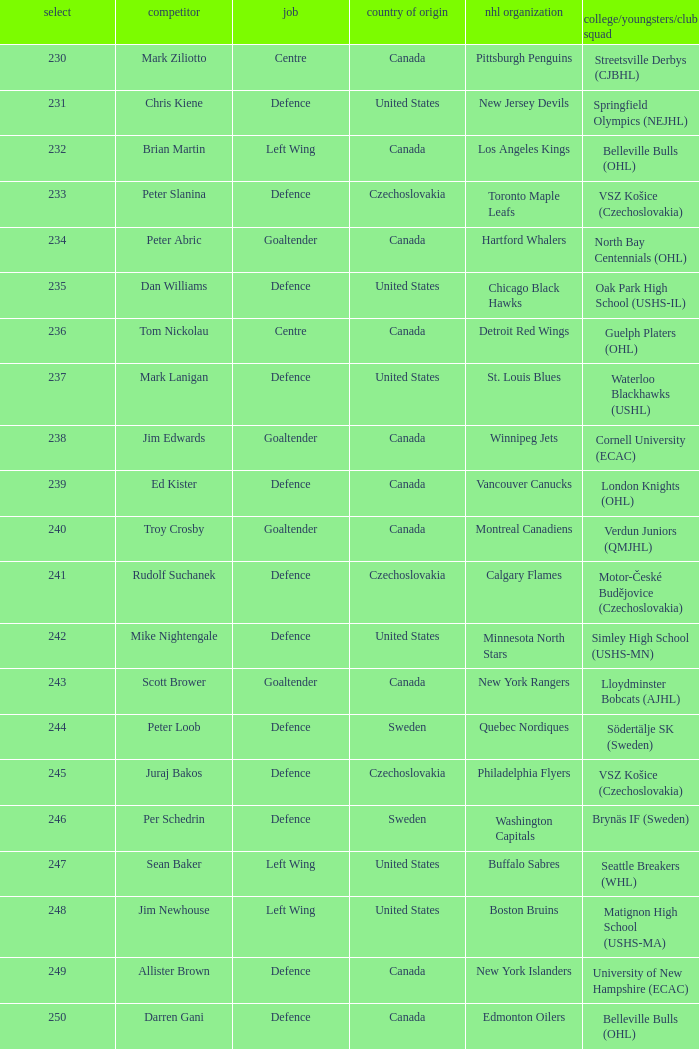List the players for team brynäs if (sweden). Per Schedrin. 